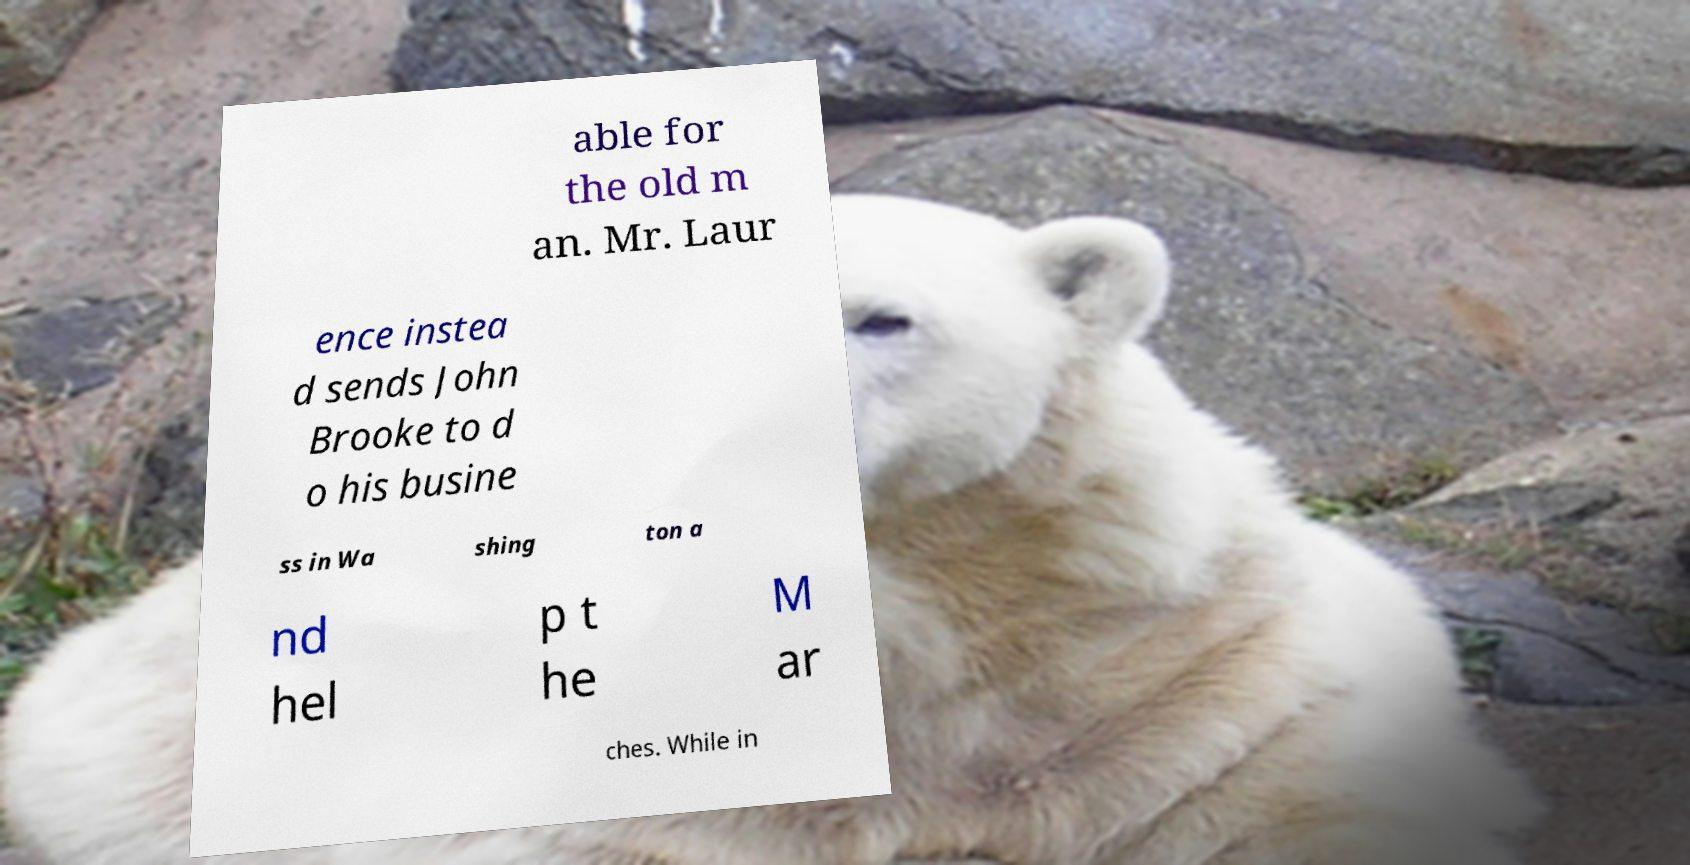What messages or text are displayed in this image? I need them in a readable, typed format. able for the old m an. Mr. Laur ence instea d sends John Brooke to d o his busine ss in Wa shing ton a nd hel p t he M ar ches. While in 